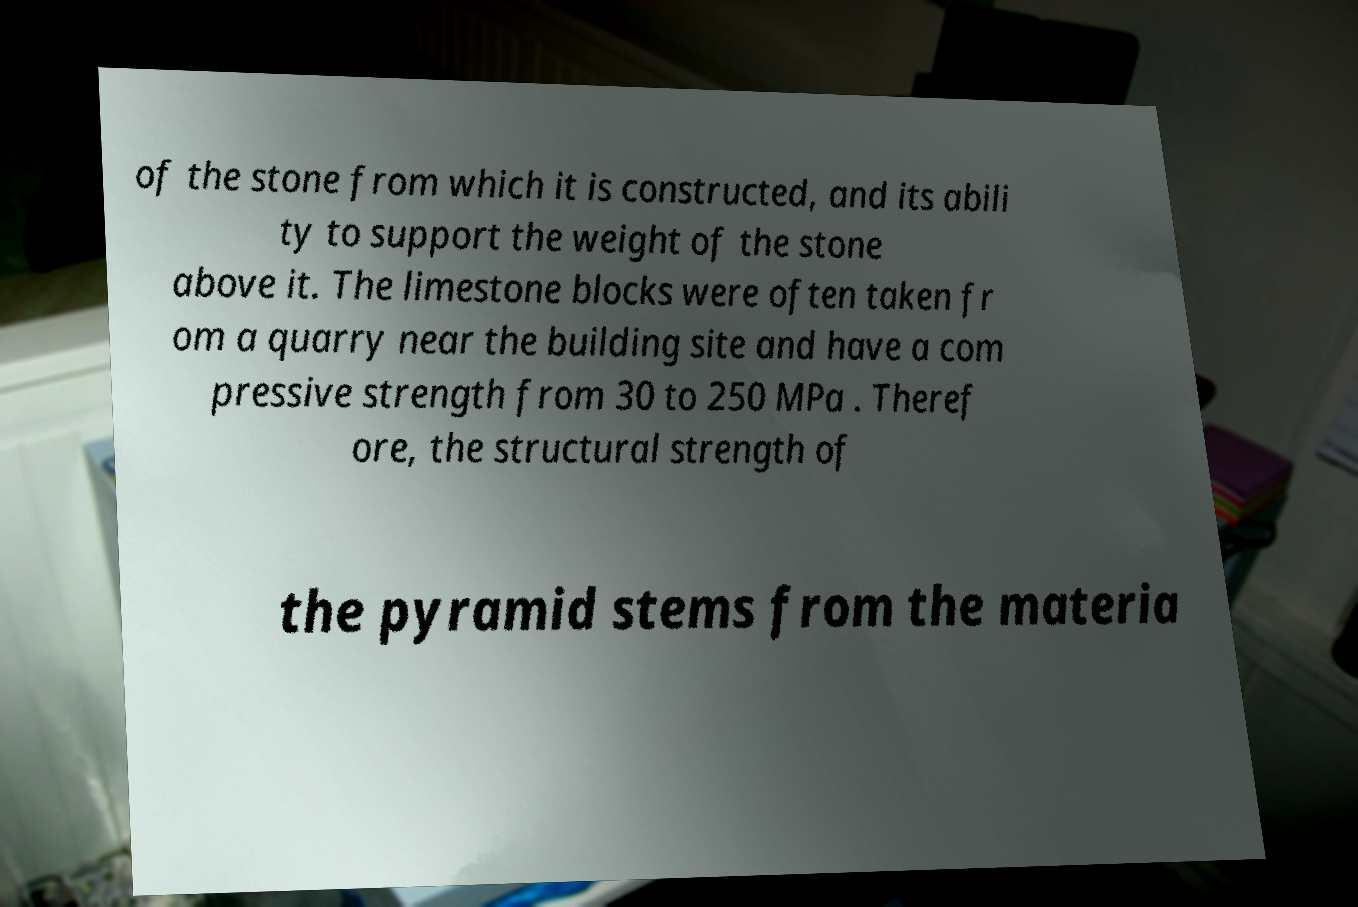There's text embedded in this image that I need extracted. Can you transcribe it verbatim? of the stone from which it is constructed, and its abili ty to support the weight of the stone above it. The limestone blocks were often taken fr om a quarry near the building site and have a com pressive strength from 30 to 250 MPa . Theref ore, the structural strength of the pyramid stems from the materia 